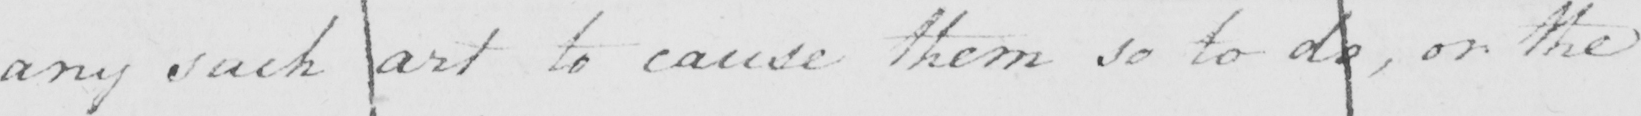Please transcribe the handwritten text in this image. any such art to cause them so to do , or the 